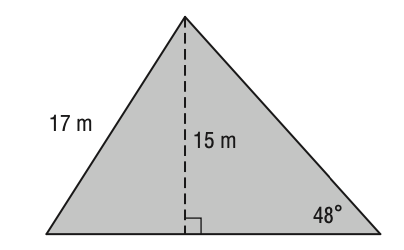Answer the mathemtical geometry problem and directly provide the correct option letter.
Question: What is the area of the triangle? Round your answer to the nearest tenth if necessary.
Choices: A: 137.4 B: 161.3 C: 170.5 D: 186.9 B 